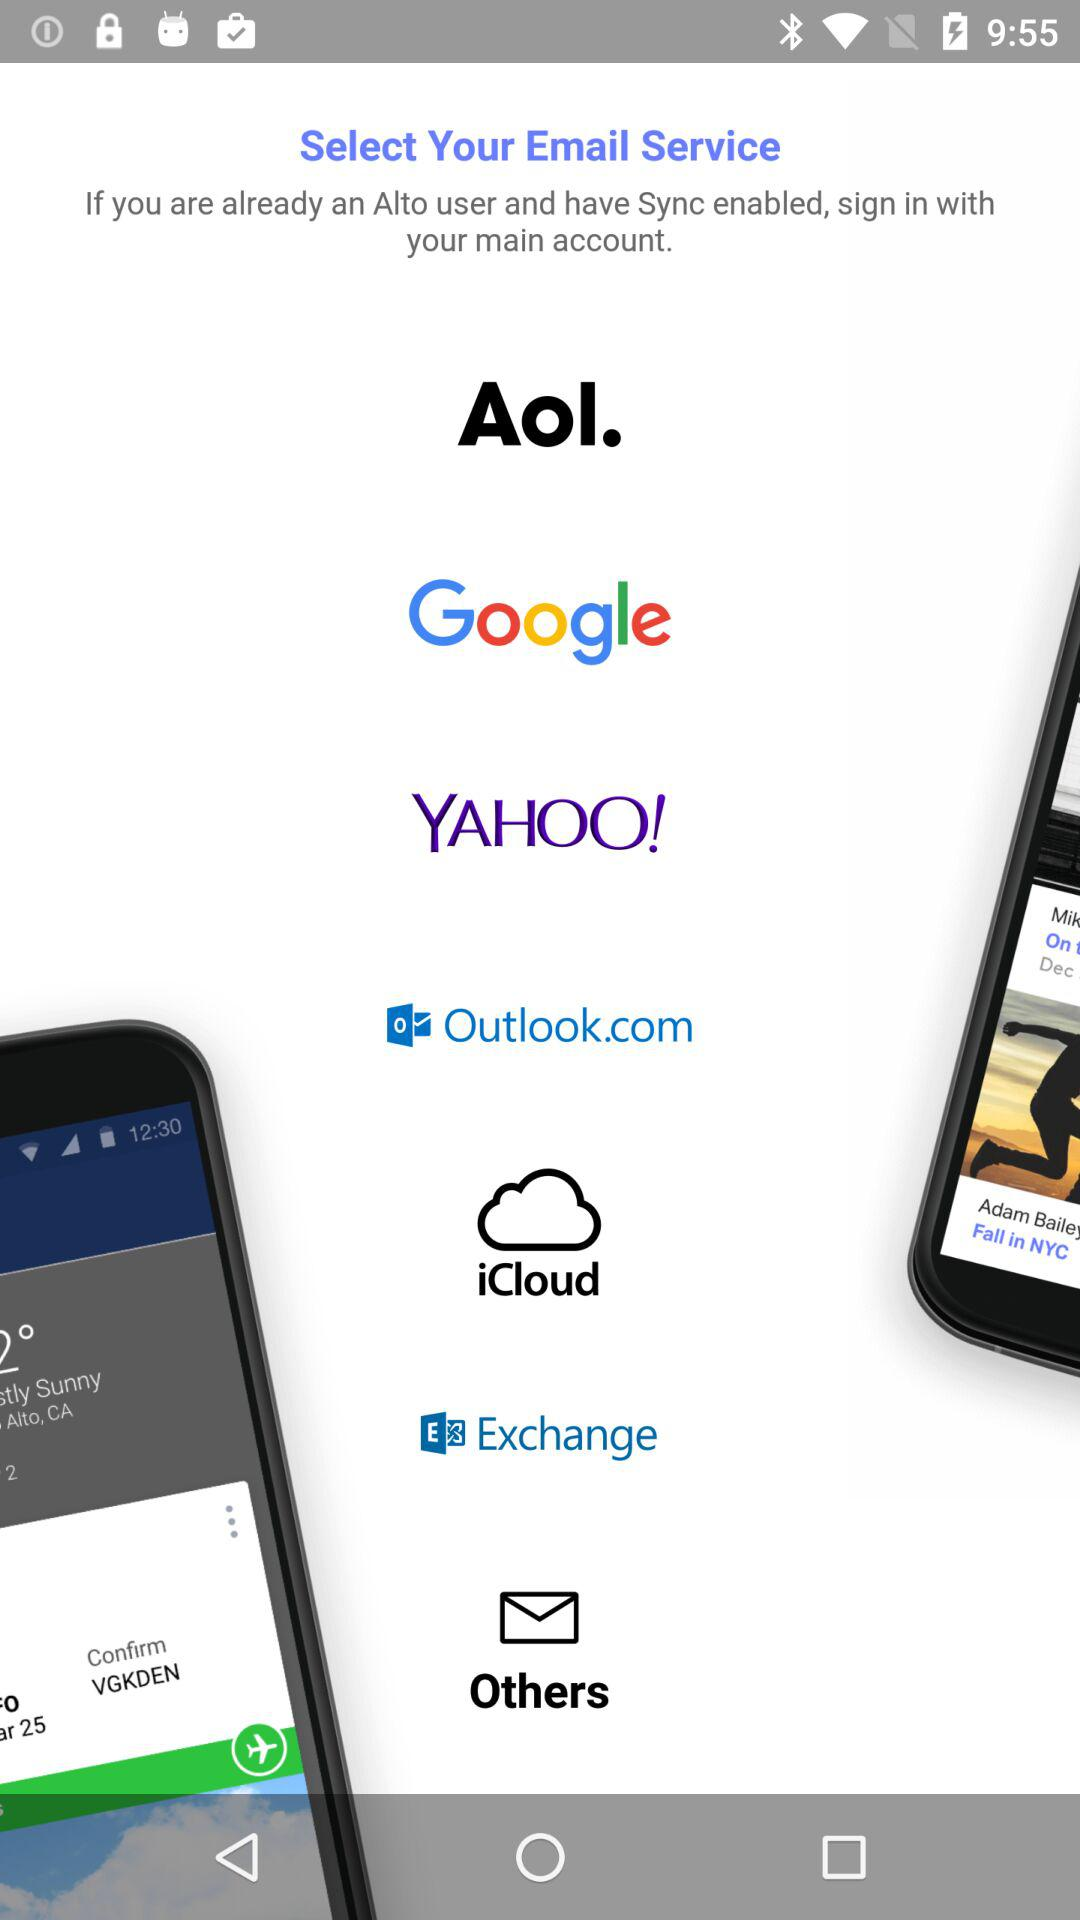Which are the different options to sign in? The different options to sign in are "Aol.", "Google", "YAHOO!", "Outlook.com", "iCloud", "Exchange" and "Others". 